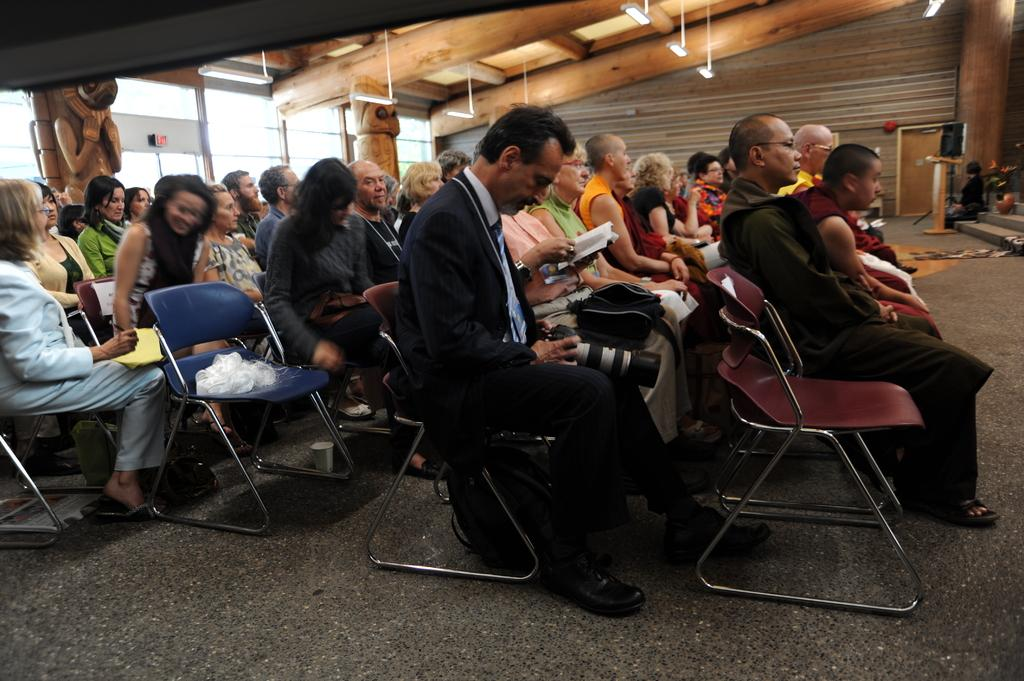How many people are in the image? There is a group of persons in the image. What are the persons doing in the image? The persons are sitting on chairs. Where is the scene taking place? The setting is in a room. How many steps are there in the image? There are no steps visible in the image; the persons are sitting on chairs in a room. 